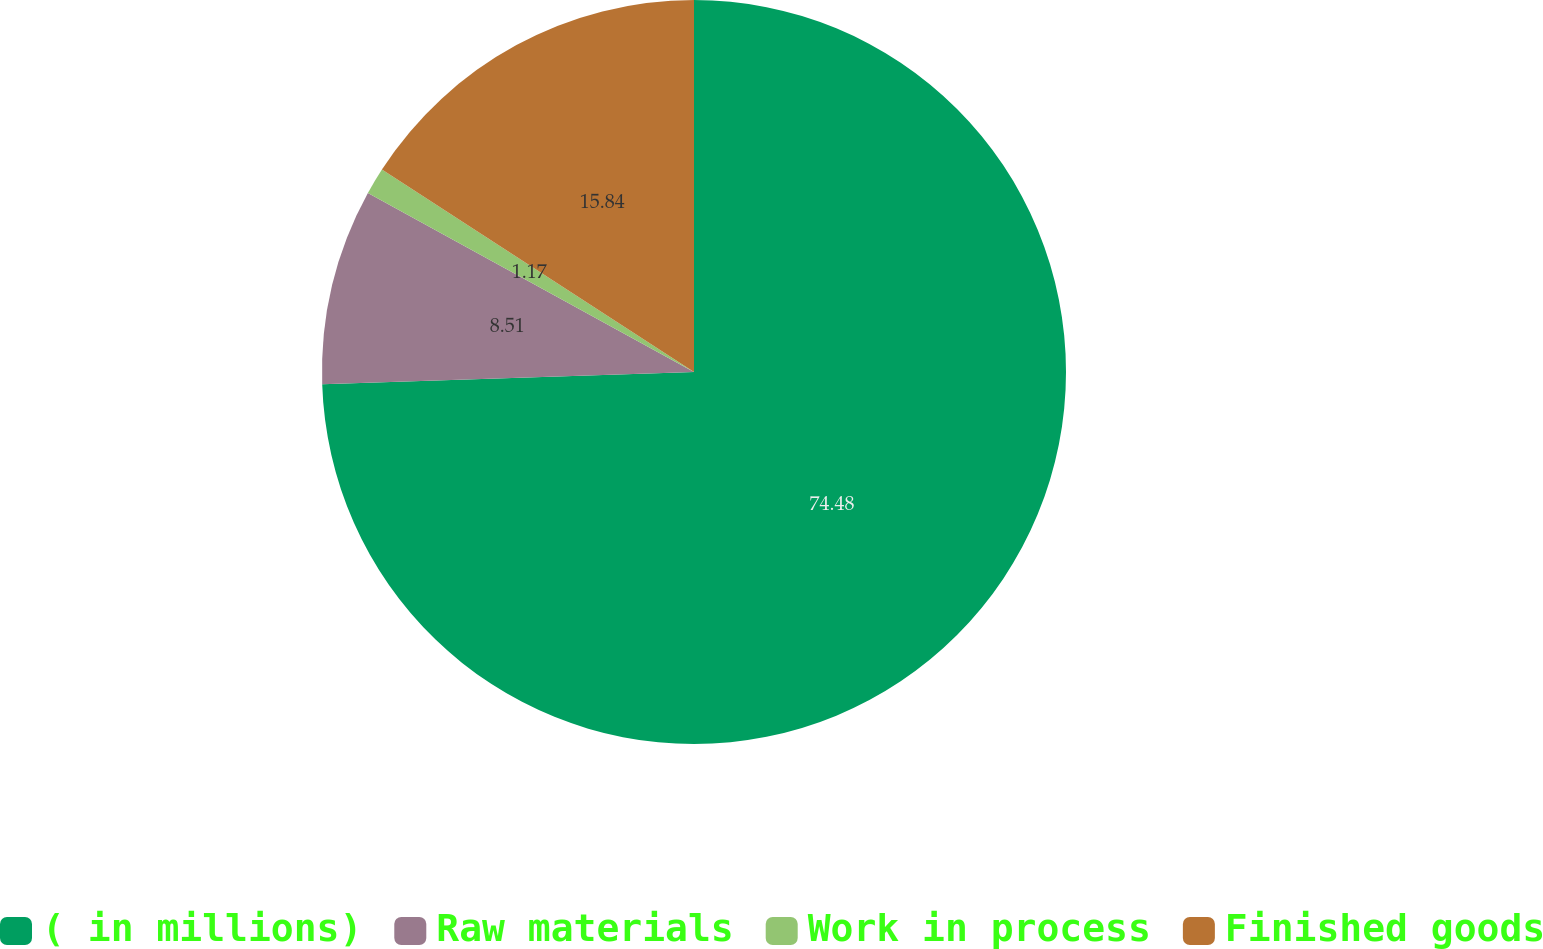Convert chart to OTSL. <chart><loc_0><loc_0><loc_500><loc_500><pie_chart><fcel>( in millions)<fcel>Raw materials<fcel>Work in process<fcel>Finished goods<nl><fcel>74.48%<fcel>8.51%<fcel>1.17%<fcel>15.84%<nl></chart> 